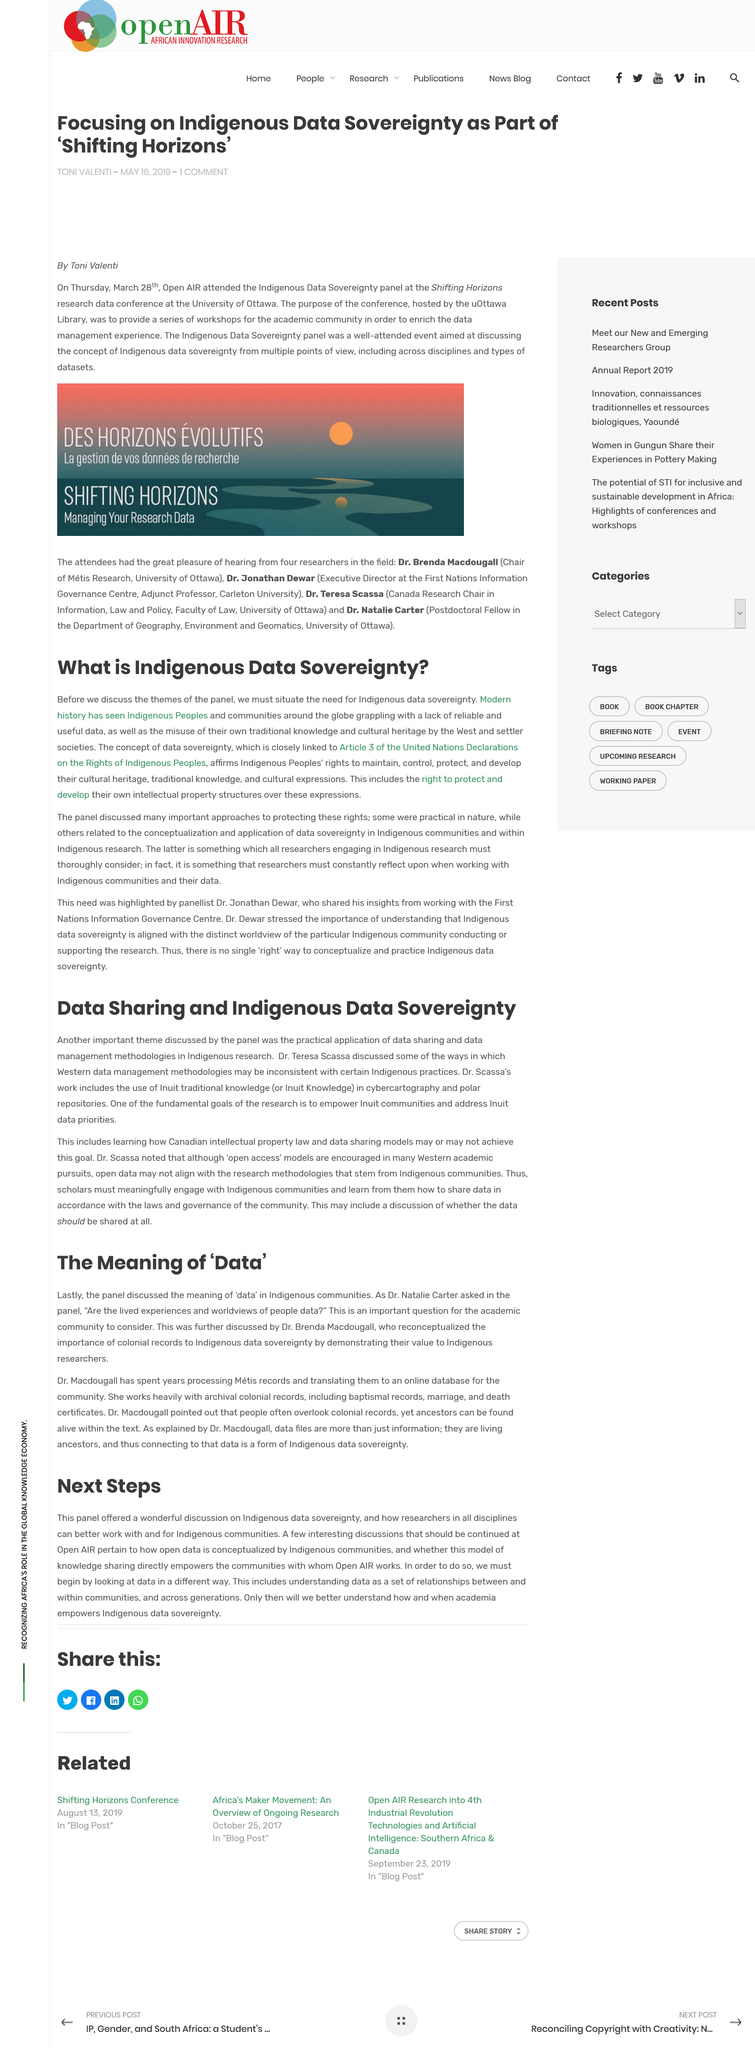Mention a couple of crucial points in this snapshot. The title of this section is 'Next Steps' and it provides information on the next steps to take after completing this section. The panel did in fact discuss the practical application of data sharing. Open AIR attended the Indigenous Data Sovereignty panel at the Shifting Horizons research data conference at the University of Ottawa on Thursday, March 28th. The panel provided a remarkable discussion on Indigenous data sovereignty, highlighting the importance of involving Indigenous communities in research and offering guidance for researchers across disciplines. Indigenous Peoples and communities have been struggling with a lack of reliable and useful data, which has hindered their ability to effectively advocate for their rights and needs. 